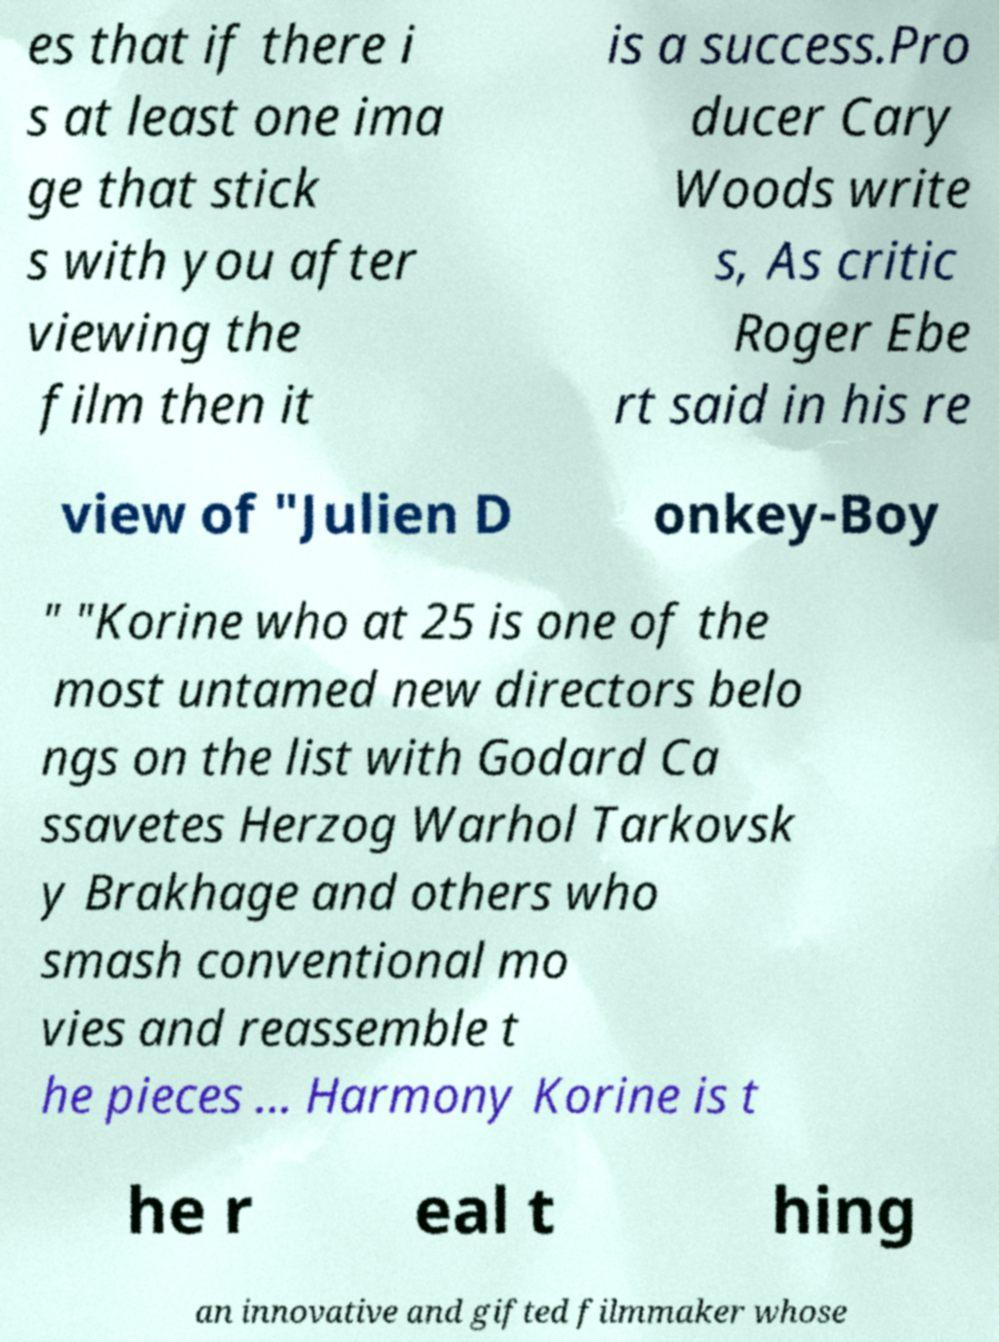Please identify and transcribe the text found in this image. es that if there i s at least one ima ge that stick s with you after viewing the film then it is a success.Pro ducer Cary Woods write s, As critic Roger Ebe rt said in his re view of "Julien D onkey-Boy " "Korine who at 25 is one of the most untamed new directors belo ngs on the list with Godard Ca ssavetes Herzog Warhol Tarkovsk y Brakhage and others who smash conventional mo vies and reassemble t he pieces ... Harmony Korine is t he r eal t hing an innovative and gifted filmmaker whose 